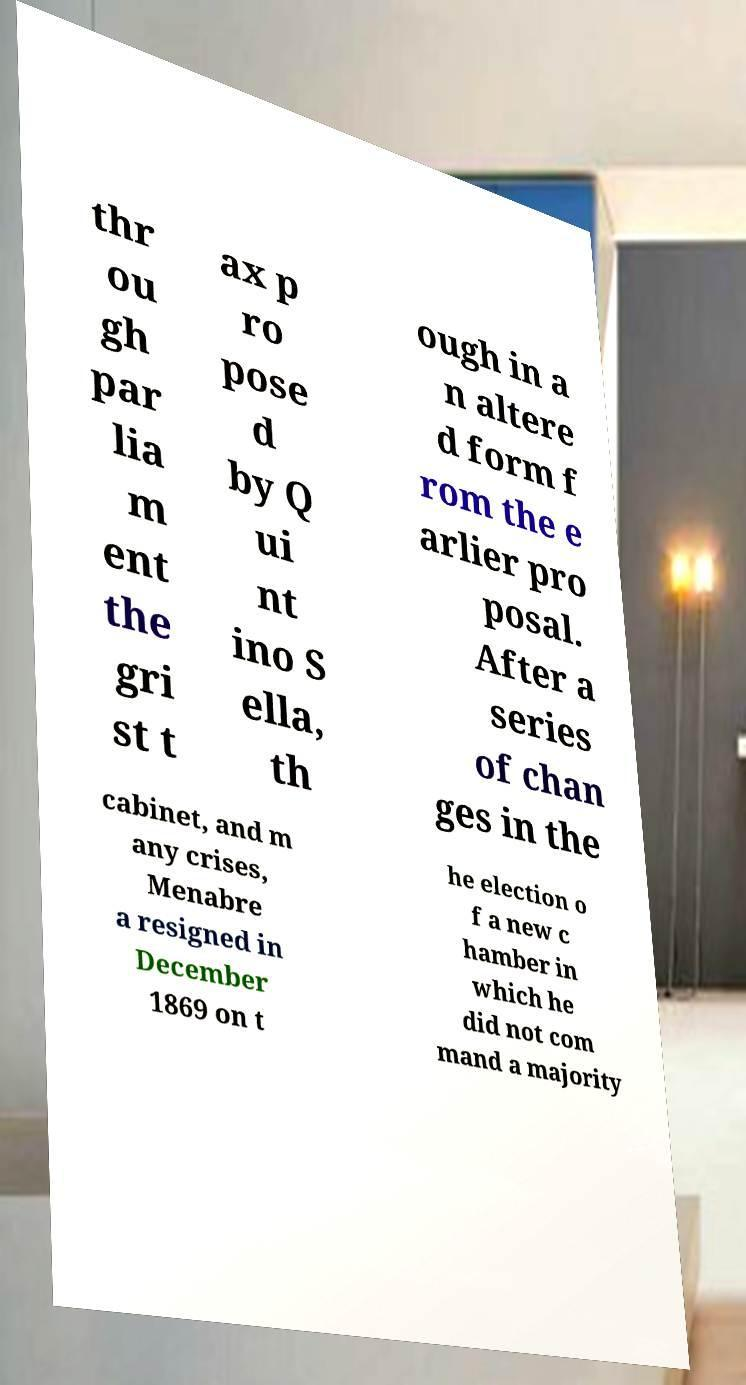For documentation purposes, I need the text within this image transcribed. Could you provide that? thr ou gh par lia m ent the gri st t ax p ro pose d by Q ui nt ino S ella, th ough in a n altere d form f rom the e arlier pro posal. After a series of chan ges in the cabinet, and m any crises, Menabre a resigned in December 1869 on t he election o f a new c hamber in which he did not com mand a majority 